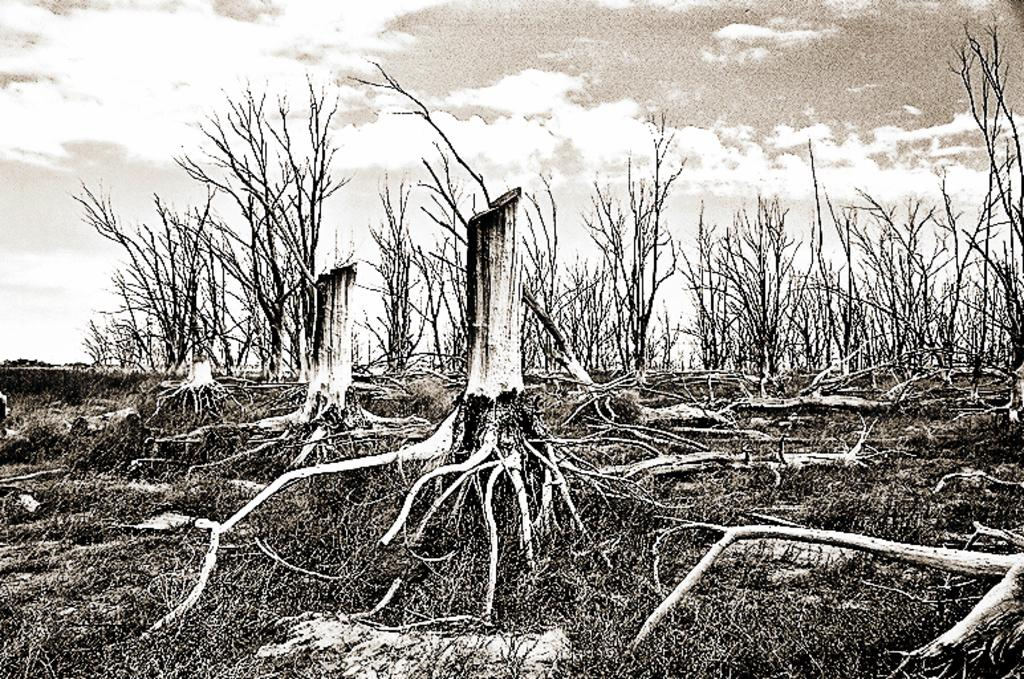What is the color scheme of the image? The image is black and white. Has the image been altered in any way? Yes, the image is edited. What type of natural elements can be seen in the image? There are many trees in the image, and their roots are visible. What is visible at the top of the image? The sky is visible at the top of the image. What type of lunch is being served in the image? There is no lunch or any food items present in the image. Can you see any donkeys in the image? There are no donkeys or any animals visible in the image. 